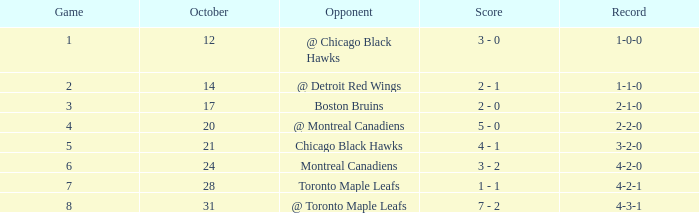Write the full table. {'header': ['Game', 'October', 'Opponent', 'Score', 'Record'], 'rows': [['1', '12', '@ Chicago Black Hawks', '3 - 0', '1-0-0'], ['2', '14', '@ Detroit Red Wings', '2 - 1', '1-1-0'], ['3', '17', 'Boston Bruins', '2 - 0', '2-1-0'], ['4', '20', '@ Montreal Canadiens', '5 - 0', '2-2-0'], ['5', '21', 'Chicago Black Hawks', '4 - 1', '3-2-0'], ['6', '24', 'Montreal Canadiens', '3 - 2', '4-2-0'], ['7', '28', 'Toronto Maple Leafs', '1 - 1', '4-2-1'], ['8', '31', '@ Toronto Maple Leafs', '7 - 2', '4-3-1']]} On october 28, what was the score after game 6? 1 - 1. 